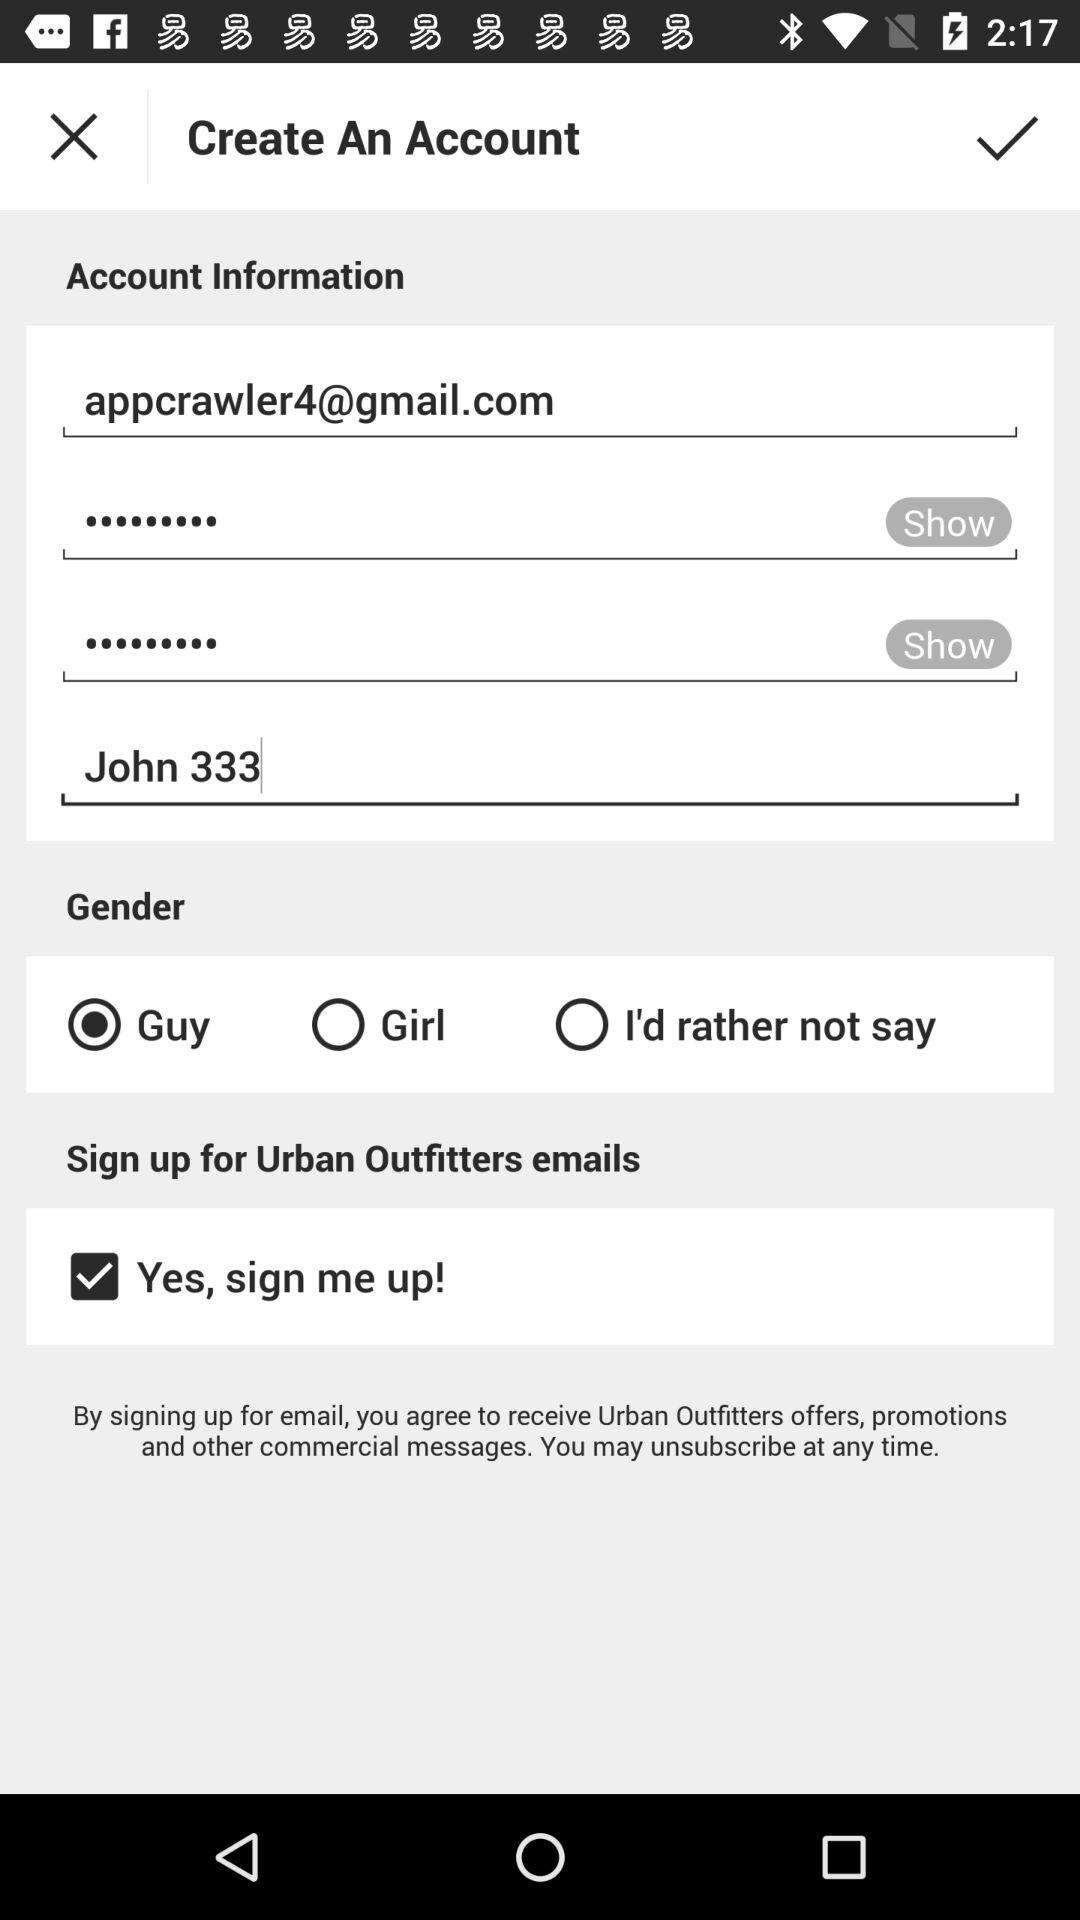What is the status of "Yes, sign me up!"? The status is "on". 